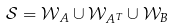Convert formula to latex. <formula><loc_0><loc_0><loc_500><loc_500>\mathcal { S } = \mathcal { W } _ { A } \cup \mathcal { W } _ { A ^ { T } } \cup \mathcal { W } _ { B }</formula> 